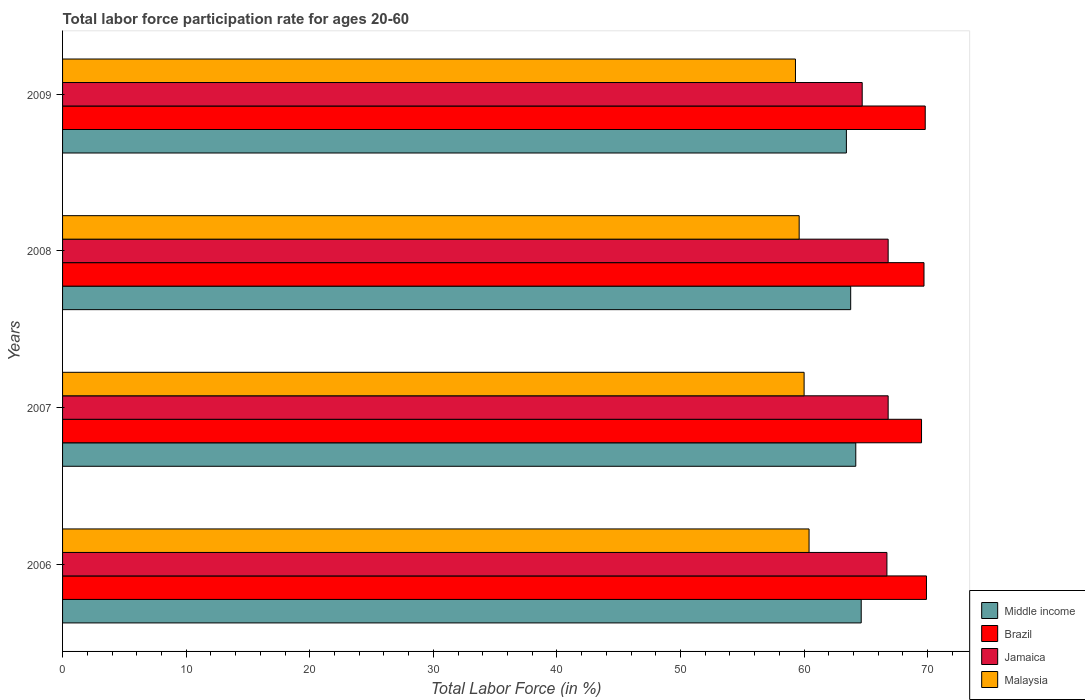How many different coloured bars are there?
Your answer should be very brief. 4. How many groups of bars are there?
Provide a short and direct response. 4. Are the number of bars per tick equal to the number of legend labels?
Ensure brevity in your answer.  Yes. Are the number of bars on each tick of the Y-axis equal?
Ensure brevity in your answer.  Yes. How many bars are there on the 1st tick from the top?
Your answer should be very brief. 4. In how many cases, is the number of bars for a given year not equal to the number of legend labels?
Your answer should be compact. 0. What is the labor force participation rate in Jamaica in 2008?
Keep it short and to the point. 66.8. Across all years, what is the maximum labor force participation rate in Middle income?
Offer a terse response. 64.62. Across all years, what is the minimum labor force participation rate in Middle income?
Your answer should be compact. 63.42. In which year was the labor force participation rate in Brazil minimum?
Keep it short and to the point. 2007. What is the total labor force participation rate in Middle income in the graph?
Ensure brevity in your answer.  255.99. What is the difference between the labor force participation rate in Jamaica in 2007 and that in 2009?
Make the answer very short. 2.1. What is the difference between the labor force participation rate in Middle income in 2006 and the labor force participation rate in Jamaica in 2007?
Keep it short and to the point. -2.18. What is the average labor force participation rate in Middle income per year?
Your response must be concise. 64. In the year 2007, what is the difference between the labor force participation rate in Jamaica and labor force participation rate in Middle income?
Provide a short and direct response. 2.62. What is the ratio of the labor force participation rate in Jamaica in 2007 to that in 2009?
Offer a terse response. 1.03. Is the difference between the labor force participation rate in Jamaica in 2007 and 2009 greater than the difference between the labor force participation rate in Middle income in 2007 and 2009?
Give a very brief answer. Yes. What is the difference between the highest and the second highest labor force participation rate in Middle income?
Offer a terse response. 0.44. What is the difference between the highest and the lowest labor force participation rate in Malaysia?
Your answer should be very brief. 1.1. Is the sum of the labor force participation rate in Middle income in 2007 and 2008 greater than the maximum labor force participation rate in Jamaica across all years?
Your response must be concise. Yes. What does the 2nd bar from the bottom in 2009 represents?
Make the answer very short. Brazil. Is it the case that in every year, the sum of the labor force participation rate in Middle income and labor force participation rate in Malaysia is greater than the labor force participation rate in Jamaica?
Provide a short and direct response. Yes. How many bars are there?
Give a very brief answer. 16. What is the difference between two consecutive major ticks on the X-axis?
Ensure brevity in your answer.  10. Are the values on the major ticks of X-axis written in scientific E-notation?
Keep it short and to the point. No. Does the graph contain any zero values?
Provide a succinct answer. No. Does the graph contain grids?
Keep it short and to the point. No. Where does the legend appear in the graph?
Make the answer very short. Bottom right. How are the legend labels stacked?
Offer a very short reply. Vertical. What is the title of the graph?
Keep it short and to the point. Total labor force participation rate for ages 20-60. Does "Ukraine" appear as one of the legend labels in the graph?
Offer a terse response. No. What is the label or title of the X-axis?
Keep it short and to the point. Total Labor Force (in %). What is the Total Labor Force (in %) in Middle income in 2006?
Offer a terse response. 64.62. What is the Total Labor Force (in %) in Brazil in 2006?
Provide a short and direct response. 69.9. What is the Total Labor Force (in %) in Jamaica in 2006?
Your answer should be compact. 66.7. What is the Total Labor Force (in %) of Malaysia in 2006?
Make the answer very short. 60.4. What is the Total Labor Force (in %) of Middle income in 2007?
Ensure brevity in your answer.  64.18. What is the Total Labor Force (in %) in Brazil in 2007?
Give a very brief answer. 69.5. What is the Total Labor Force (in %) in Jamaica in 2007?
Make the answer very short. 66.8. What is the Total Labor Force (in %) in Malaysia in 2007?
Keep it short and to the point. 60. What is the Total Labor Force (in %) in Middle income in 2008?
Make the answer very short. 63.77. What is the Total Labor Force (in %) in Brazil in 2008?
Keep it short and to the point. 69.7. What is the Total Labor Force (in %) in Jamaica in 2008?
Provide a succinct answer. 66.8. What is the Total Labor Force (in %) of Malaysia in 2008?
Ensure brevity in your answer.  59.6. What is the Total Labor Force (in %) of Middle income in 2009?
Your answer should be compact. 63.42. What is the Total Labor Force (in %) in Brazil in 2009?
Offer a very short reply. 69.8. What is the Total Labor Force (in %) of Jamaica in 2009?
Your answer should be very brief. 64.7. What is the Total Labor Force (in %) of Malaysia in 2009?
Your response must be concise. 59.3. Across all years, what is the maximum Total Labor Force (in %) in Middle income?
Offer a very short reply. 64.62. Across all years, what is the maximum Total Labor Force (in %) of Brazil?
Make the answer very short. 69.9. Across all years, what is the maximum Total Labor Force (in %) in Jamaica?
Offer a terse response. 66.8. Across all years, what is the maximum Total Labor Force (in %) in Malaysia?
Provide a succinct answer. 60.4. Across all years, what is the minimum Total Labor Force (in %) of Middle income?
Provide a succinct answer. 63.42. Across all years, what is the minimum Total Labor Force (in %) in Brazil?
Your response must be concise. 69.5. Across all years, what is the minimum Total Labor Force (in %) in Jamaica?
Provide a succinct answer. 64.7. Across all years, what is the minimum Total Labor Force (in %) of Malaysia?
Ensure brevity in your answer.  59.3. What is the total Total Labor Force (in %) of Middle income in the graph?
Your answer should be very brief. 255.99. What is the total Total Labor Force (in %) in Brazil in the graph?
Keep it short and to the point. 278.9. What is the total Total Labor Force (in %) in Jamaica in the graph?
Offer a terse response. 265. What is the total Total Labor Force (in %) of Malaysia in the graph?
Make the answer very short. 239.3. What is the difference between the Total Labor Force (in %) in Middle income in 2006 and that in 2007?
Your answer should be compact. 0.44. What is the difference between the Total Labor Force (in %) of Malaysia in 2006 and that in 2007?
Make the answer very short. 0.4. What is the difference between the Total Labor Force (in %) of Middle income in 2006 and that in 2008?
Your answer should be compact. 0.85. What is the difference between the Total Labor Force (in %) of Malaysia in 2006 and that in 2008?
Provide a succinct answer. 0.8. What is the difference between the Total Labor Force (in %) of Middle income in 2006 and that in 2009?
Keep it short and to the point. 1.2. What is the difference between the Total Labor Force (in %) of Middle income in 2007 and that in 2008?
Give a very brief answer. 0.41. What is the difference between the Total Labor Force (in %) of Brazil in 2007 and that in 2008?
Provide a succinct answer. -0.2. What is the difference between the Total Labor Force (in %) in Jamaica in 2007 and that in 2008?
Keep it short and to the point. 0. What is the difference between the Total Labor Force (in %) in Malaysia in 2007 and that in 2008?
Your answer should be compact. 0.4. What is the difference between the Total Labor Force (in %) in Middle income in 2007 and that in 2009?
Offer a very short reply. 0.76. What is the difference between the Total Labor Force (in %) in Brazil in 2007 and that in 2009?
Give a very brief answer. -0.3. What is the difference between the Total Labor Force (in %) in Malaysia in 2007 and that in 2009?
Your response must be concise. 0.7. What is the difference between the Total Labor Force (in %) of Middle income in 2008 and that in 2009?
Provide a short and direct response. 0.35. What is the difference between the Total Labor Force (in %) of Brazil in 2008 and that in 2009?
Provide a short and direct response. -0.1. What is the difference between the Total Labor Force (in %) in Jamaica in 2008 and that in 2009?
Keep it short and to the point. 2.1. What is the difference between the Total Labor Force (in %) in Malaysia in 2008 and that in 2009?
Offer a terse response. 0.3. What is the difference between the Total Labor Force (in %) of Middle income in 2006 and the Total Labor Force (in %) of Brazil in 2007?
Keep it short and to the point. -4.88. What is the difference between the Total Labor Force (in %) in Middle income in 2006 and the Total Labor Force (in %) in Jamaica in 2007?
Offer a terse response. -2.18. What is the difference between the Total Labor Force (in %) of Middle income in 2006 and the Total Labor Force (in %) of Malaysia in 2007?
Offer a terse response. 4.62. What is the difference between the Total Labor Force (in %) in Brazil in 2006 and the Total Labor Force (in %) in Jamaica in 2007?
Keep it short and to the point. 3.1. What is the difference between the Total Labor Force (in %) in Middle income in 2006 and the Total Labor Force (in %) in Brazil in 2008?
Ensure brevity in your answer.  -5.08. What is the difference between the Total Labor Force (in %) in Middle income in 2006 and the Total Labor Force (in %) in Jamaica in 2008?
Keep it short and to the point. -2.18. What is the difference between the Total Labor Force (in %) of Middle income in 2006 and the Total Labor Force (in %) of Malaysia in 2008?
Ensure brevity in your answer.  5.02. What is the difference between the Total Labor Force (in %) in Brazil in 2006 and the Total Labor Force (in %) in Malaysia in 2008?
Offer a terse response. 10.3. What is the difference between the Total Labor Force (in %) of Middle income in 2006 and the Total Labor Force (in %) of Brazil in 2009?
Your answer should be compact. -5.18. What is the difference between the Total Labor Force (in %) in Middle income in 2006 and the Total Labor Force (in %) in Jamaica in 2009?
Offer a terse response. -0.08. What is the difference between the Total Labor Force (in %) in Middle income in 2006 and the Total Labor Force (in %) in Malaysia in 2009?
Keep it short and to the point. 5.32. What is the difference between the Total Labor Force (in %) in Brazil in 2006 and the Total Labor Force (in %) in Malaysia in 2009?
Your response must be concise. 10.6. What is the difference between the Total Labor Force (in %) of Jamaica in 2006 and the Total Labor Force (in %) of Malaysia in 2009?
Offer a terse response. 7.4. What is the difference between the Total Labor Force (in %) in Middle income in 2007 and the Total Labor Force (in %) in Brazil in 2008?
Offer a terse response. -5.52. What is the difference between the Total Labor Force (in %) of Middle income in 2007 and the Total Labor Force (in %) of Jamaica in 2008?
Provide a succinct answer. -2.62. What is the difference between the Total Labor Force (in %) in Middle income in 2007 and the Total Labor Force (in %) in Malaysia in 2008?
Give a very brief answer. 4.58. What is the difference between the Total Labor Force (in %) of Middle income in 2007 and the Total Labor Force (in %) of Brazil in 2009?
Your answer should be very brief. -5.62. What is the difference between the Total Labor Force (in %) in Middle income in 2007 and the Total Labor Force (in %) in Jamaica in 2009?
Ensure brevity in your answer.  -0.52. What is the difference between the Total Labor Force (in %) in Middle income in 2007 and the Total Labor Force (in %) in Malaysia in 2009?
Ensure brevity in your answer.  4.88. What is the difference between the Total Labor Force (in %) of Brazil in 2007 and the Total Labor Force (in %) of Jamaica in 2009?
Provide a short and direct response. 4.8. What is the difference between the Total Labor Force (in %) in Brazil in 2007 and the Total Labor Force (in %) in Malaysia in 2009?
Your answer should be very brief. 10.2. What is the difference between the Total Labor Force (in %) in Middle income in 2008 and the Total Labor Force (in %) in Brazil in 2009?
Provide a succinct answer. -6.03. What is the difference between the Total Labor Force (in %) in Middle income in 2008 and the Total Labor Force (in %) in Jamaica in 2009?
Your response must be concise. -0.93. What is the difference between the Total Labor Force (in %) in Middle income in 2008 and the Total Labor Force (in %) in Malaysia in 2009?
Your answer should be very brief. 4.47. What is the difference between the Total Labor Force (in %) of Brazil in 2008 and the Total Labor Force (in %) of Malaysia in 2009?
Offer a terse response. 10.4. What is the average Total Labor Force (in %) in Middle income per year?
Your answer should be compact. 64. What is the average Total Labor Force (in %) in Brazil per year?
Your answer should be very brief. 69.72. What is the average Total Labor Force (in %) of Jamaica per year?
Offer a terse response. 66.25. What is the average Total Labor Force (in %) of Malaysia per year?
Provide a short and direct response. 59.83. In the year 2006, what is the difference between the Total Labor Force (in %) in Middle income and Total Labor Force (in %) in Brazil?
Your response must be concise. -5.28. In the year 2006, what is the difference between the Total Labor Force (in %) in Middle income and Total Labor Force (in %) in Jamaica?
Offer a terse response. -2.08. In the year 2006, what is the difference between the Total Labor Force (in %) of Middle income and Total Labor Force (in %) of Malaysia?
Your response must be concise. 4.22. In the year 2006, what is the difference between the Total Labor Force (in %) of Brazil and Total Labor Force (in %) of Jamaica?
Provide a short and direct response. 3.2. In the year 2006, what is the difference between the Total Labor Force (in %) in Brazil and Total Labor Force (in %) in Malaysia?
Keep it short and to the point. 9.5. In the year 2007, what is the difference between the Total Labor Force (in %) in Middle income and Total Labor Force (in %) in Brazil?
Offer a very short reply. -5.32. In the year 2007, what is the difference between the Total Labor Force (in %) in Middle income and Total Labor Force (in %) in Jamaica?
Your answer should be very brief. -2.62. In the year 2007, what is the difference between the Total Labor Force (in %) of Middle income and Total Labor Force (in %) of Malaysia?
Provide a succinct answer. 4.18. In the year 2007, what is the difference between the Total Labor Force (in %) in Brazil and Total Labor Force (in %) in Jamaica?
Make the answer very short. 2.7. In the year 2007, what is the difference between the Total Labor Force (in %) of Jamaica and Total Labor Force (in %) of Malaysia?
Offer a very short reply. 6.8. In the year 2008, what is the difference between the Total Labor Force (in %) of Middle income and Total Labor Force (in %) of Brazil?
Provide a short and direct response. -5.93. In the year 2008, what is the difference between the Total Labor Force (in %) in Middle income and Total Labor Force (in %) in Jamaica?
Offer a very short reply. -3.03. In the year 2008, what is the difference between the Total Labor Force (in %) of Middle income and Total Labor Force (in %) of Malaysia?
Your response must be concise. 4.17. In the year 2008, what is the difference between the Total Labor Force (in %) in Brazil and Total Labor Force (in %) in Jamaica?
Keep it short and to the point. 2.9. In the year 2008, what is the difference between the Total Labor Force (in %) in Brazil and Total Labor Force (in %) in Malaysia?
Offer a terse response. 10.1. In the year 2008, what is the difference between the Total Labor Force (in %) in Jamaica and Total Labor Force (in %) in Malaysia?
Your answer should be compact. 7.2. In the year 2009, what is the difference between the Total Labor Force (in %) of Middle income and Total Labor Force (in %) of Brazil?
Make the answer very short. -6.38. In the year 2009, what is the difference between the Total Labor Force (in %) of Middle income and Total Labor Force (in %) of Jamaica?
Offer a very short reply. -1.28. In the year 2009, what is the difference between the Total Labor Force (in %) in Middle income and Total Labor Force (in %) in Malaysia?
Keep it short and to the point. 4.12. In the year 2009, what is the difference between the Total Labor Force (in %) in Brazil and Total Labor Force (in %) in Jamaica?
Ensure brevity in your answer.  5.1. What is the ratio of the Total Labor Force (in %) in Middle income in 2006 to that in 2007?
Your answer should be very brief. 1.01. What is the ratio of the Total Labor Force (in %) of Brazil in 2006 to that in 2007?
Provide a short and direct response. 1.01. What is the ratio of the Total Labor Force (in %) in Middle income in 2006 to that in 2008?
Give a very brief answer. 1.01. What is the ratio of the Total Labor Force (in %) of Jamaica in 2006 to that in 2008?
Give a very brief answer. 1. What is the ratio of the Total Labor Force (in %) of Malaysia in 2006 to that in 2008?
Provide a succinct answer. 1.01. What is the ratio of the Total Labor Force (in %) in Middle income in 2006 to that in 2009?
Your response must be concise. 1.02. What is the ratio of the Total Labor Force (in %) in Jamaica in 2006 to that in 2009?
Your answer should be very brief. 1.03. What is the ratio of the Total Labor Force (in %) in Malaysia in 2006 to that in 2009?
Provide a succinct answer. 1.02. What is the ratio of the Total Labor Force (in %) of Brazil in 2007 to that in 2008?
Your answer should be very brief. 1. What is the ratio of the Total Labor Force (in %) of Jamaica in 2007 to that in 2008?
Give a very brief answer. 1. What is the ratio of the Total Labor Force (in %) in Malaysia in 2007 to that in 2008?
Your answer should be compact. 1.01. What is the ratio of the Total Labor Force (in %) of Middle income in 2007 to that in 2009?
Your answer should be compact. 1.01. What is the ratio of the Total Labor Force (in %) in Brazil in 2007 to that in 2009?
Offer a very short reply. 1. What is the ratio of the Total Labor Force (in %) of Jamaica in 2007 to that in 2009?
Your answer should be very brief. 1.03. What is the ratio of the Total Labor Force (in %) of Malaysia in 2007 to that in 2009?
Your response must be concise. 1.01. What is the ratio of the Total Labor Force (in %) of Middle income in 2008 to that in 2009?
Provide a short and direct response. 1.01. What is the ratio of the Total Labor Force (in %) of Jamaica in 2008 to that in 2009?
Keep it short and to the point. 1.03. What is the ratio of the Total Labor Force (in %) of Malaysia in 2008 to that in 2009?
Give a very brief answer. 1.01. What is the difference between the highest and the second highest Total Labor Force (in %) in Middle income?
Provide a succinct answer. 0.44. What is the difference between the highest and the second highest Total Labor Force (in %) of Malaysia?
Ensure brevity in your answer.  0.4. What is the difference between the highest and the lowest Total Labor Force (in %) of Middle income?
Your answer should be very brief. 1.2. What is the difference between the highest and the lowest Total Labor Force (in %) of Brazil?
Provide a short and direct response. 0.4. 